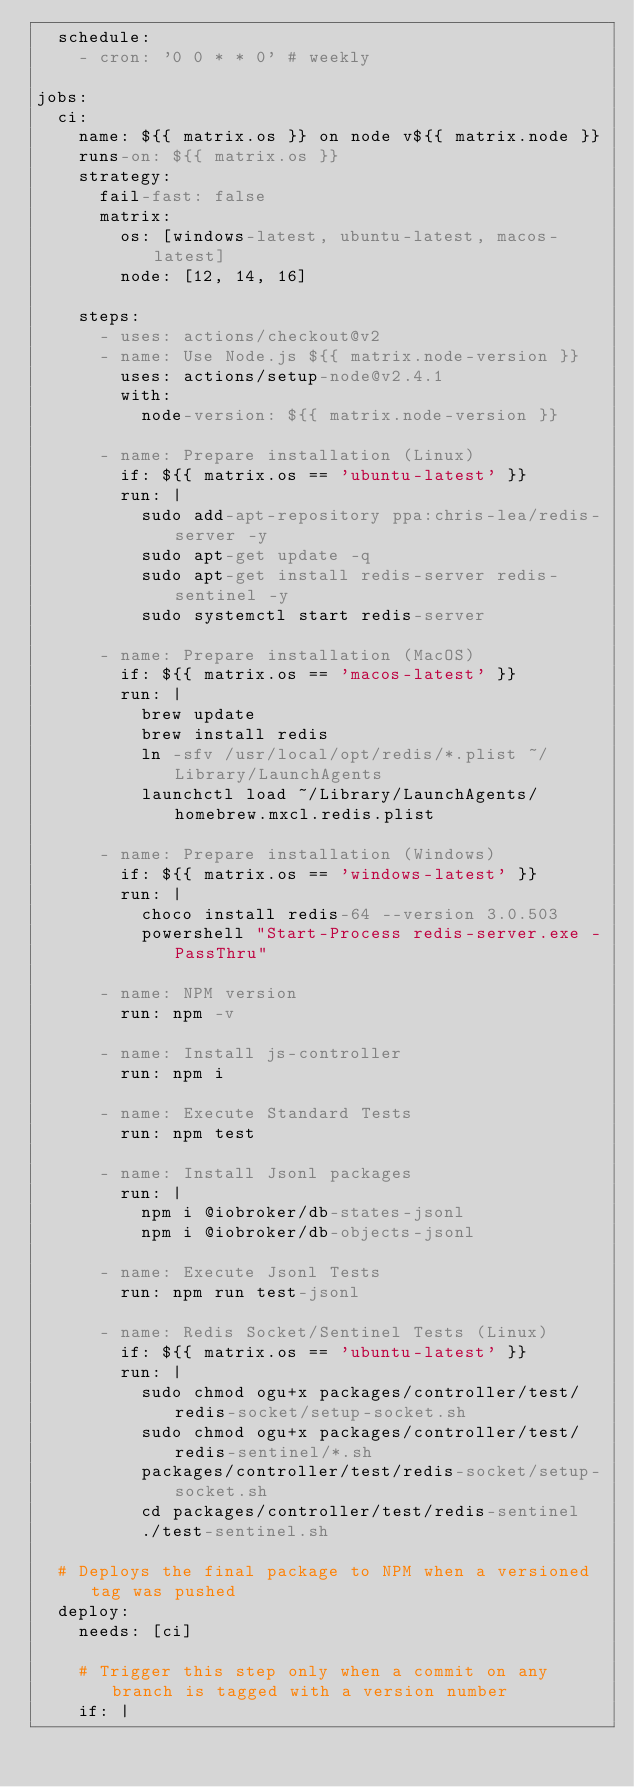Convert code to text. <code><loc_0><loc_0><loc_500><loc_500><_YAML_>  schedule:
    - cron: '0 0 * * 0' # weekly

jobs:
  ci:
    name: ${{ matrix.os }} on node v${{ matrix.node }}
    runs-on: ${{ matrix.os }}
    strategy:
      fail-fast: false
      matrix:
        os: [windows-latest, ubuntu-latest, macos-latest]
        node: [12, 14, 16]

    steps:
      - uses: actions/checkout@v2
      - name: Use Node.js ${{ matrix.node-version }}
        uses: actions/setup-node@v2.4.1
        with:
          node-version: ${{ matrix.node-version }}

      - name: Prepare installation (Linux)
        if: ${{ matrix.os == 'ubuntu-latest' }}
        run: |
          sudo add-apt-repository ppa:chris-lea/redis-server -y
          sudo apt-get update -q
          sudo apt-get install redis-server redis-sentinel -y
          sudo systemctl start redis-server

      - name: Prepare installation (MacOS)
        if: ${{ matrix.os == 'macos-latest' }}
        run: |
          brew update
          brew install redis
          ln -sfv /usr/local/opt/redis/*.plist ~/Library/LaunchAgents
          launchctl load ~/Library/LaunchAgents/homebrew.mxcl.redis.plist

      - name: Prepare installation (Windows)
        if: ${{ matrix.os == 'windows-latest' }}
        run: |
          choco install redis-64 --version 3.0.503
          powershell "Start-Process redis-server.exe -PassThru"

      - name: NPM version
        run: npm -v

      - name: Install js-controller
        run: npm i

      - name: Execute Standard Tests
        run: npm test

      - name: Install Jsonl packages
        run: |
          npm i @iobroker/db-states-jsonl
          npm i @iobroker/db-objects-jsonl

      - name: Execute Jsonl Tests
        run: npm run test-jsonl

      - name: Redis Socket/Sentinel Tests (Linux)
        if: ${{ matrix.os == 'ubuntu-latest' }}
        run: |
          sudo chmod ogu+x packages/controller/test/redis-socket/setup-socket.sh
          sudo chmod ogu+x packages/controller/test/redis-sentinel/*.sh
          packages/controller/test/redis-socket/setup-socket.sh
          cd packages/controller/test/redis-sentinel
          ./test-sentinel.sh

  # Deploys the final package to NPM when a versioned tag was pushed
  deploy:
    needs: [ci]

    # Trigger this step only when a commit on any branch is tagged with a version number
    if: |</code> 